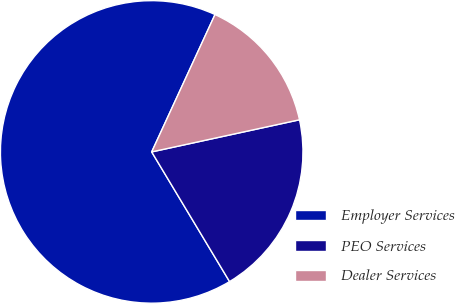Convert chart to OTSL. <chart><loc_0><loc_0><loc_500><loc_500><pie_chart><fcel>Employer Services<fcel>PEO Services<fcel>Dealer Services<nl><fcel>65.48%<fcel>19.8%<fcel>14.72%<nl></chart> 